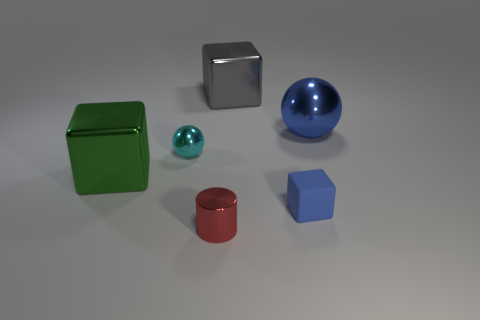Subtract all green spheres. Subtract all cyan cylinders. How many spheres are left? 2 Add 4 cyan shiny objects. How many objects exist? 10 Subtract all cylinders. How many objects are left? 5 Subtract 1 cyan spheres. How many objects are left? 5 Subtract all brown rubber balls. Subtract all big gray shiny objects. How many objects are left? 5 Add 5 large green metal things. How many large green metal things are left? 6 Add 5 blue spheres. How many blue spheres exist? 6 